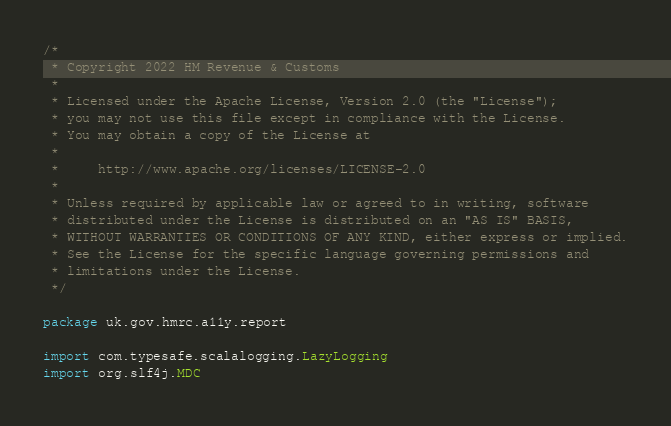<code> <loc_0><loc_0><loc_500><loc_500><_Scala_>/*
 * Copyright 2022 HM Revenue & Customs
 *
 * Licensed under the Apache License, Version 2.0 (the "License");
 * you may not use this file except in compliance with the License.
 * You may obtain a copy of the License at
 *
 *     http://www.apache.org/licenses/LICENSE-2.0
 *
 * Unless required by applicable law or agreed to in writing, software
 * distributed under the License is distributed on an "AS IS" BASIS,
 * WITHOUT WARRANTIES OR CONDITIONS OF ANY KIND, either express or implied.
 * See the License for the specific language governing permissions and
 * limitations under the License.
 */

package uk.gov.hmrc.a11y.report

import com.typesafe.scalalogging.LazyLogging
import org.slf4j.MDC
</code> 